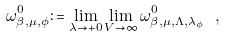Convert formula to latex. <formula><loc_0><loc_0><loc_500><loc_500>\omega ^ { 0 } _ { \beta , \mu , \phi } \colon = \lim _ { \lambda \to + 0 } \lim _ { V \to \infty } \omega ^ { 0 } _ { \beta , \mu , \Lambda , \lambda _ { \phi } } \ ,</formula> 